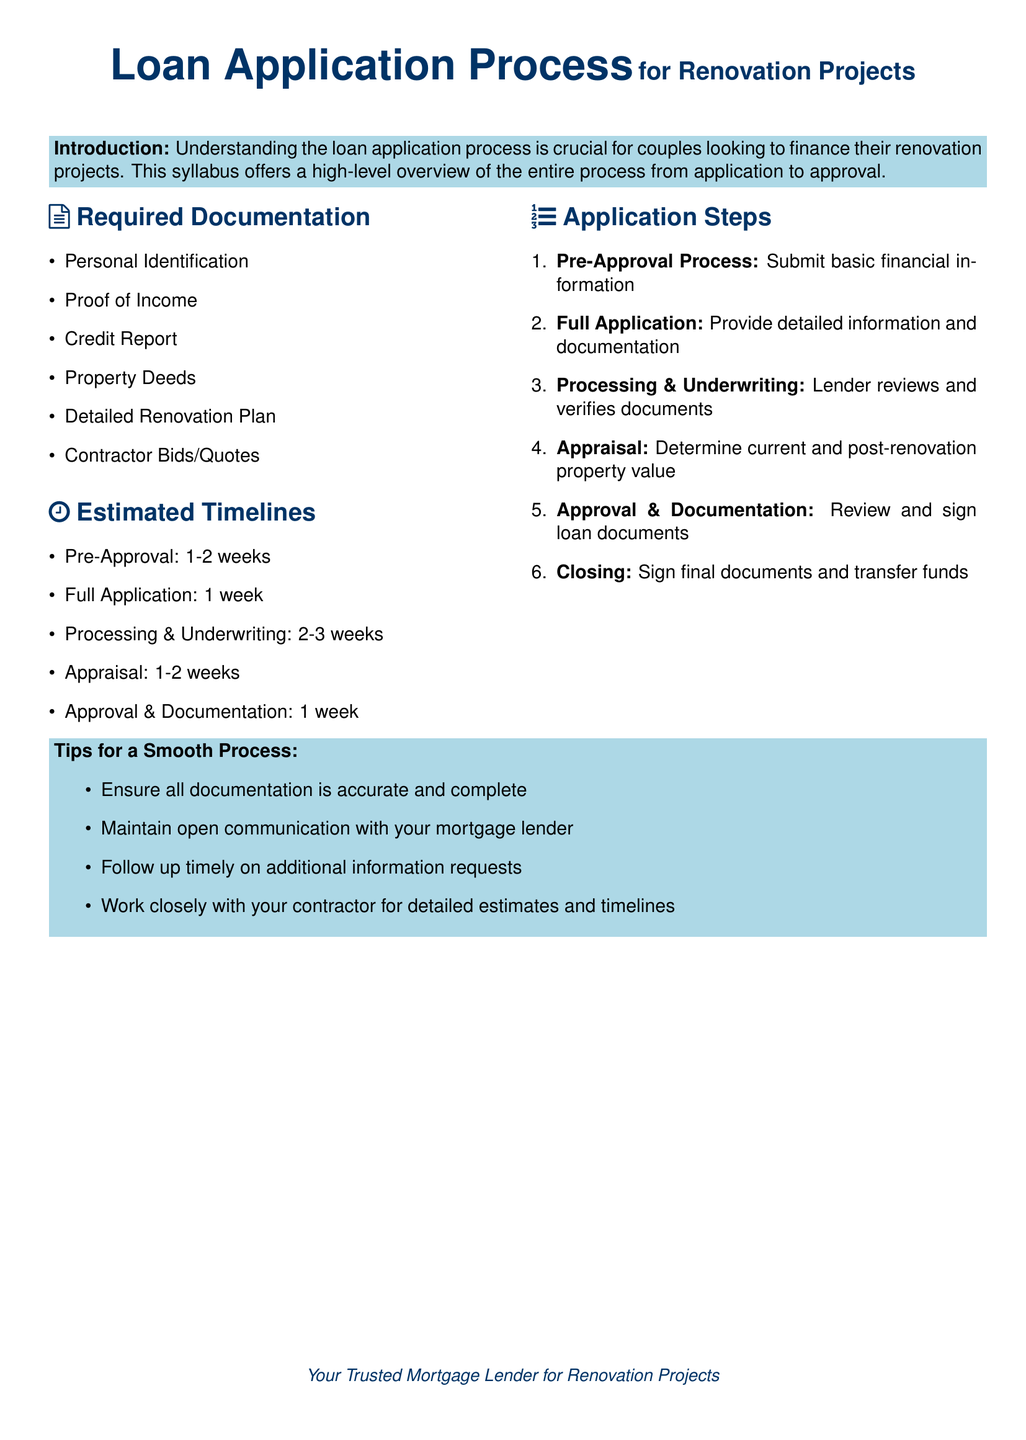What is the total required time for the loan application process? To find the total required time, the estimated timelines for each step need to be added together, yielding around 6-10 weeks depending on the individual steps taken.
Answer: 6-10 weeks What is the first step in the application process? The first step outlined in the application steps is the pre-approval process, which involves submitting basic financial information.
Answer: Pre-Approval Process How many types of documentation are required? The document lists six types of documentation necessary for the loan application process.
Answer: Six What is the average time for the processing and underwriting step? The estimated timeline for processing and underwriting is given as 2-3 weeks, which is the average duration for that step.
Answer: 2-3 weeks What document is needed to verify income? Among the listed required documentation, proof of income is specifically needed to verify the couple's income.
Answer: Proof of Income What is a key tip for a smooth loan application process? The tips section suggests maintaining open communication with the mortgage lender as a key point to ensure a smooth process.
Answer: Open communication What do couples need to provide for property valuation? The appraisal step involves determining the current and post-renovation property value, requiring relevant information for evaluation.
Answer: Appraisal What is included in the detailed renovation plan? The detailed renovation plan is mentioned in the required documentation to outline what the renovation project entails.
Answer: Detailed Renovation Plan 